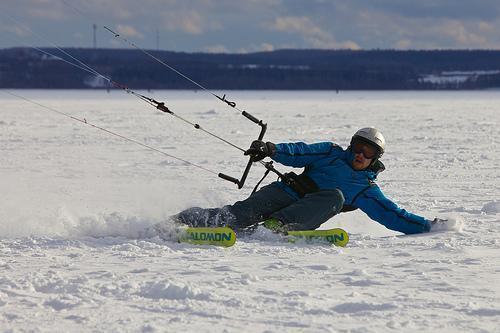How many people are in the photo?
Give a very brief answer. 1. 